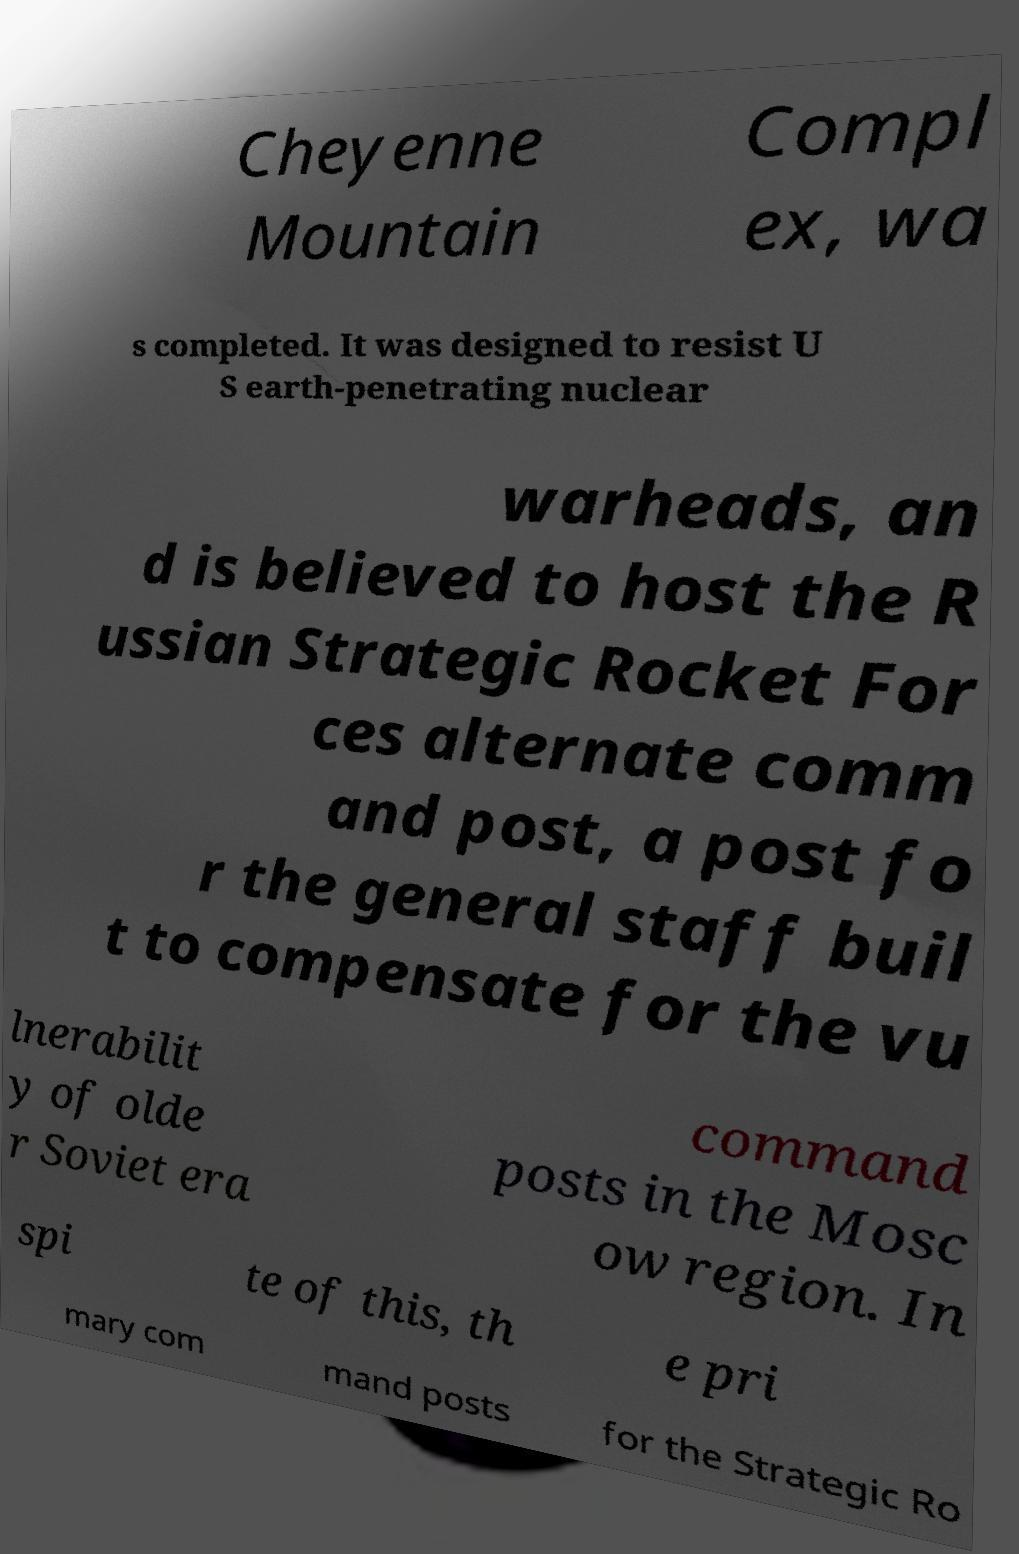Can you read and provide the text displayed in the image?This photo seems to have some interesting text. Can you extract and type it out for me? Cheyenne Mountain Compl ex, wa s completed. It was designed to resist U S earth-penetrating nuclear warheads, an d is believed to host the R ussian Strategic Rocket For ces alternate comm and post, a post fo r the general staff buil t to compensate for the vu lnerabilit y of olde r Soviet era command posts in the Mosc ow region. In spi te of this, th e pri mary com mand posts for the Strategic Ro 